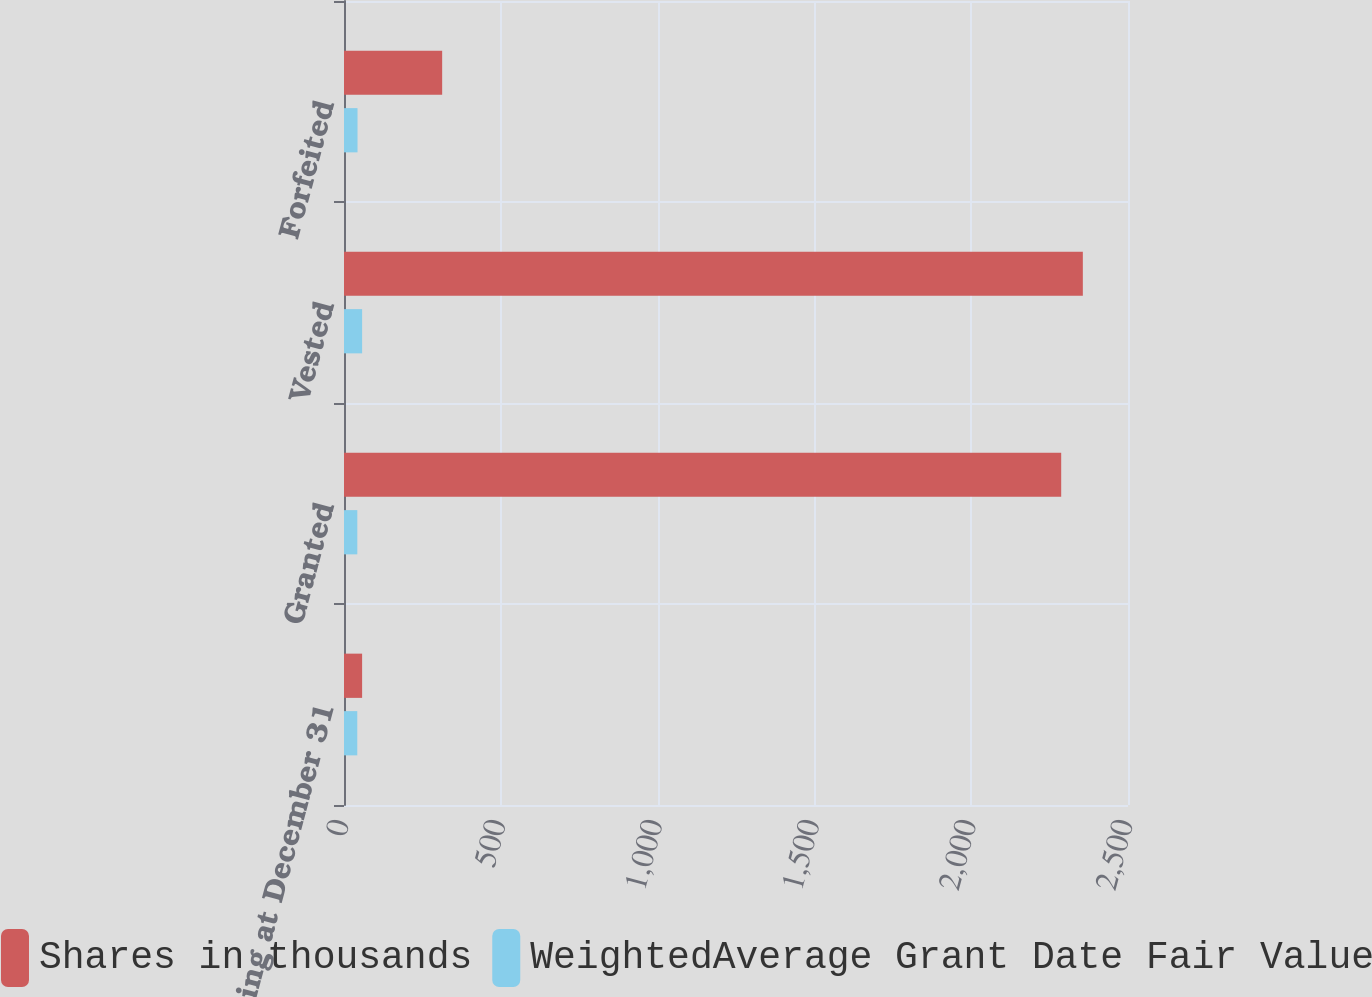<chart> <loc_0><loc_0><loc_500><loc_500><stacked_bar_chart><ecel><fcel>Outstanding at December 31<fcel>Granted<fcel>Vested<fcel>Forfeited<nl><fcel>Shares in thousands<fcel>57.76<fcel>2287<fcel>2356<fcel>313<nl><fcel>WeightedAverage Grant Date Fair Value<fcel>42.34<fcel>42.45<fcel>57.76<fcel>43.13<nl></chart> 